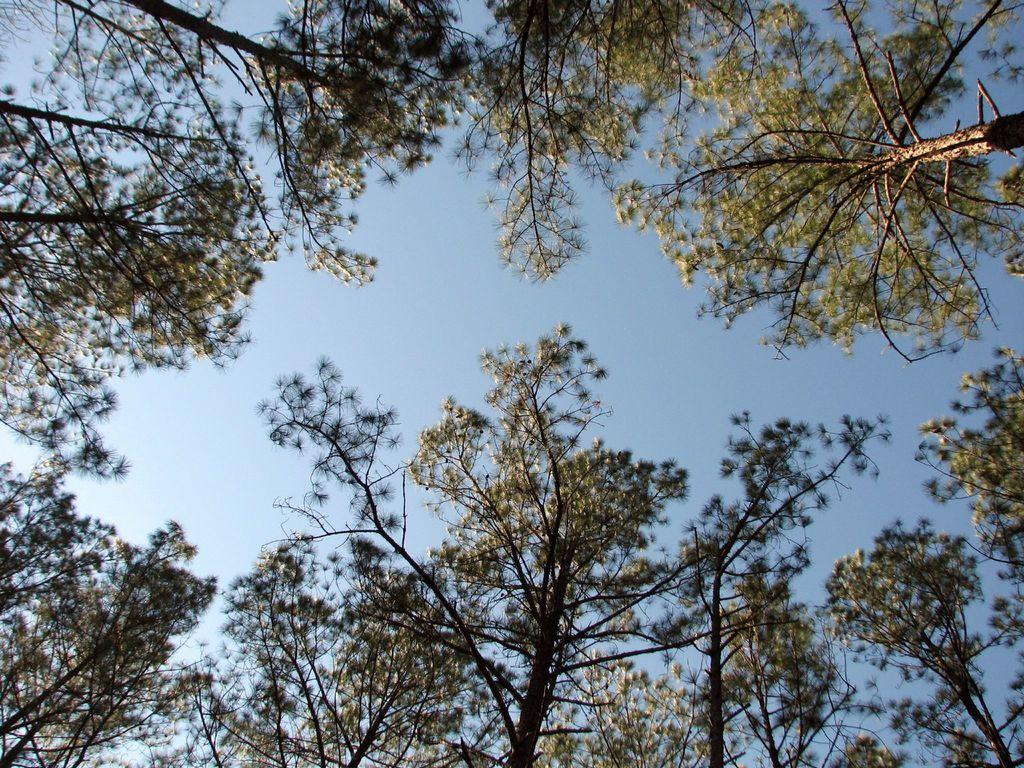What type of natural environment is depicted in the image? The image features many trees, indicating a forest or wooded area. What can be seen in the sky in the image? The sky is visible in the image, but no specific details about the sky are mentioned in the facts. What type of structure is hidden behind the trees in the image? There is no mention of a structure in the image, so we cannot determine if one is hidden behind the trees. 